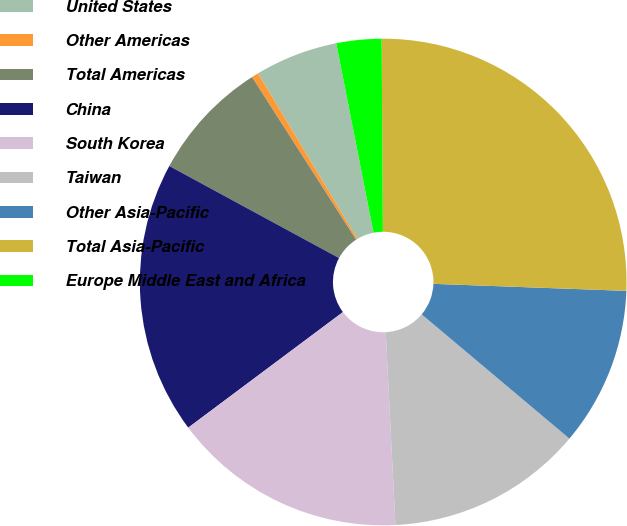Convert chart to OTSL. <chart><loc_0><loc_0><loc_500><loc_500><pie_chart><fcel>United States<fcel>Other Americas<fcel>Total Americas<fcel>China<fcel>South Korea<fcel>Taiwan<fcel>Other Asia-Pacific<fcel>Total Asia-Pacific<fcel>Europe Middle East and Africa<nl><fcel>5.51%<fcel>0.46%<fcel>8.03%<fcel>18.12%<fcel>15.59%<fcel>13.07%<fcel>10.55%<fcel>25.68%<fcel>2.99%<nl></chart> 